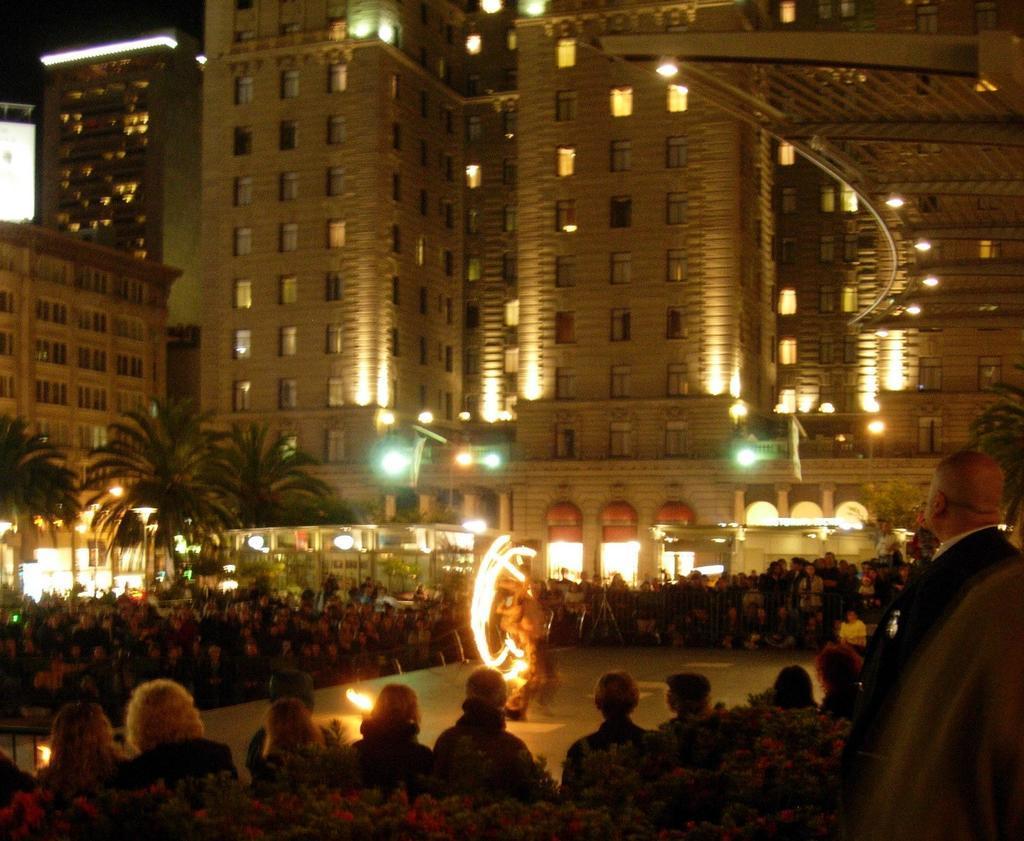Please provide a concise description of this image. In this picture I can see group of people, there are plants, there is a person playing with fire, there are trees, lights, poles, flags, buildings. 